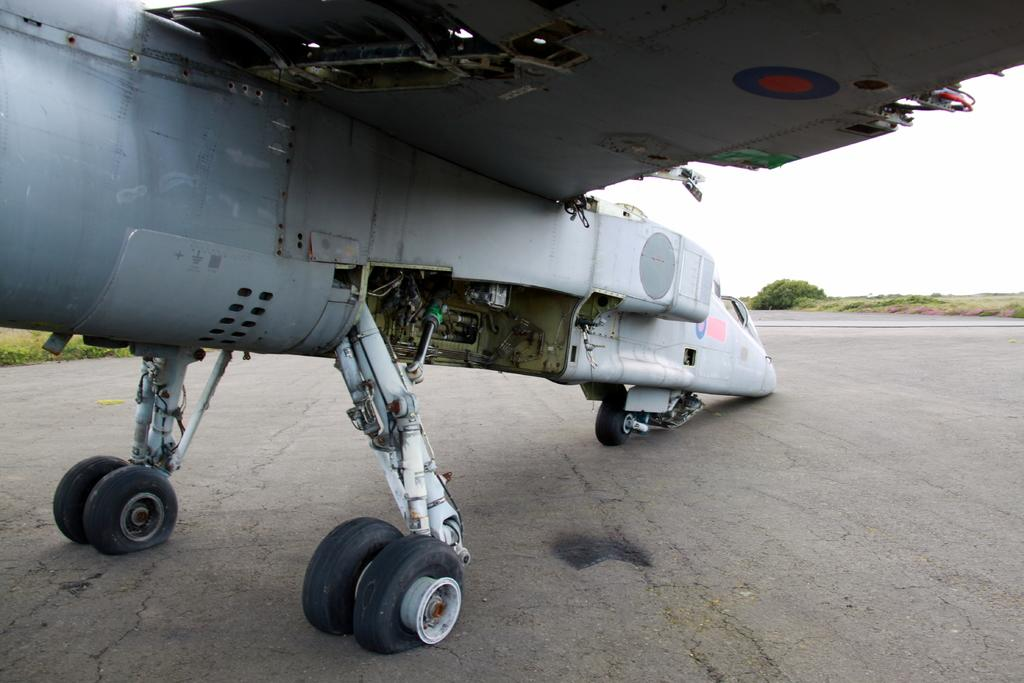What is the main subject of the image? The main subject of the image is an aircraft. What is the color of the aircraft? The aircraft is white in color. Where is the aircraft located in the image? The aircraft is on the road. What can be seen in the background of the image? Plants, grass, and the white sky are visible in the background. What type of cherry is being used as a propeller for the aircraft in the image? There is no cherry present in the image, and the aircraft's propeller is not made of a cherry. Can you see any animals interacting with the aircraft in the image? There are no animals visible in the image, and they are not interacting with the aircraft. 